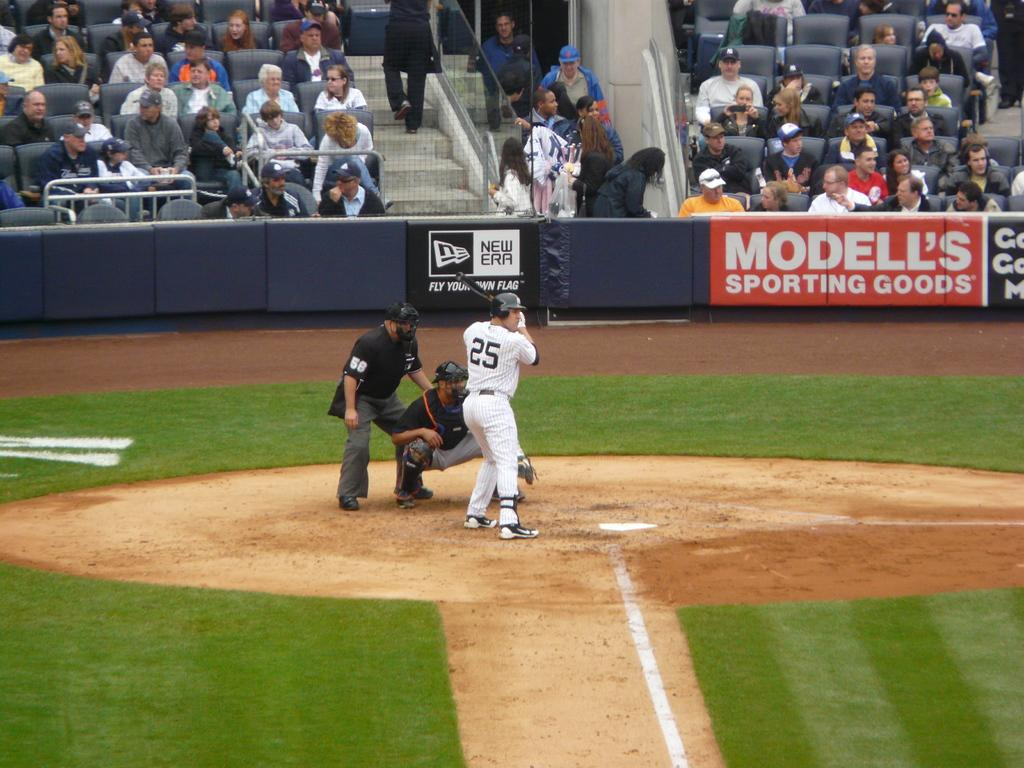<image>
Render a clear and concise summary of the photo. During a baseball game, player number 25 is at bat. 